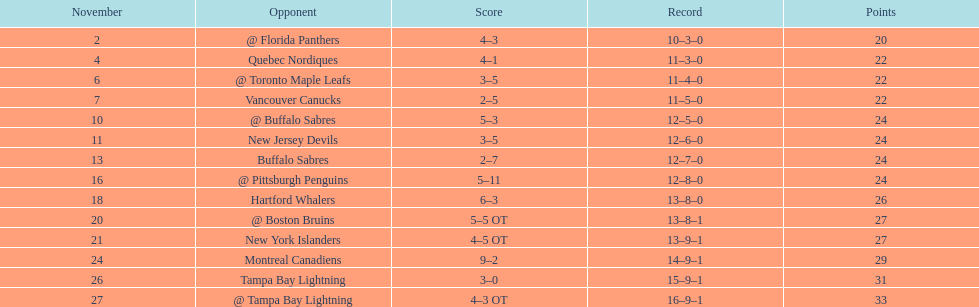Which teams scored 35 points or more in total? Hartford Whalers, @ Boston Bruins, New York Islanders, Montreal Canadiens, Tampa Bay Lightning, @ Tampa Bay Lightning. Of those teams, which team was the only one to score 3-0? Tampa Bay Lightning. 